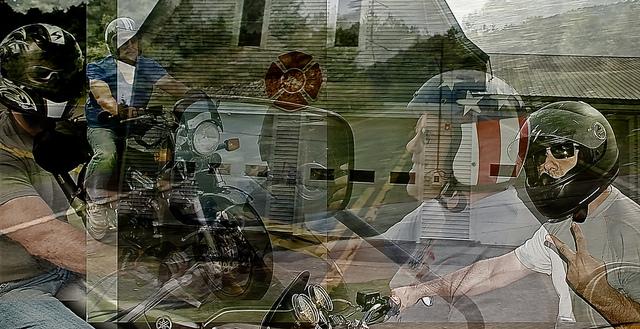Is the photo clear?
Quick response, please. No. How many motorcycles?
Write a very short answer. 2. No it is blurry?
Give a very brief answer. Yes. 